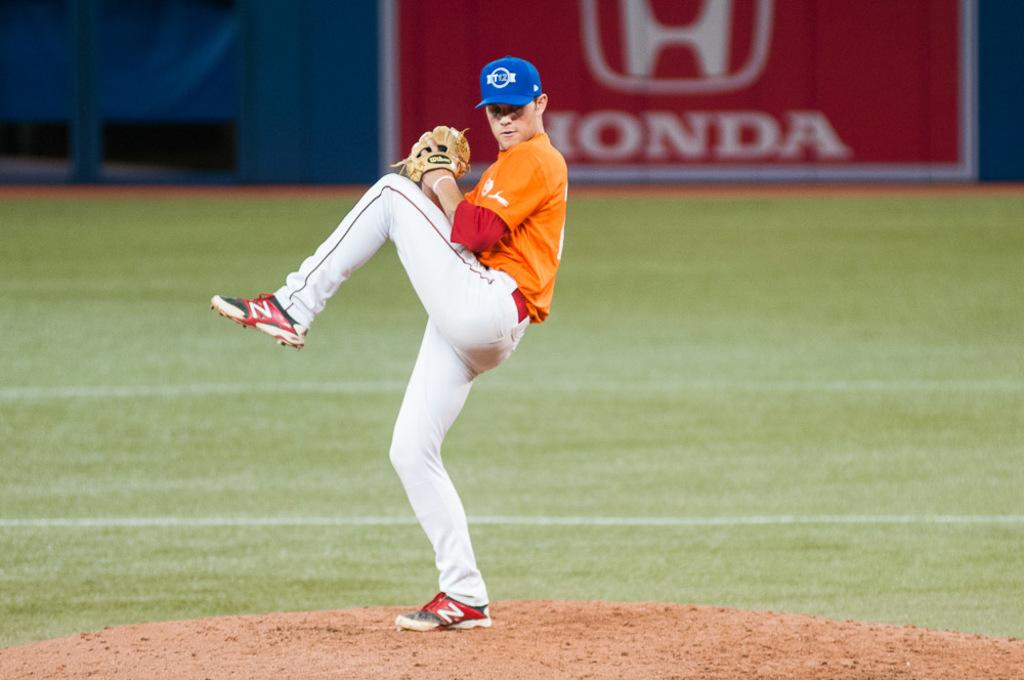<image>
Write a terse but informative summary of the picture. a person pitching a ball with a Honda sign behind them 